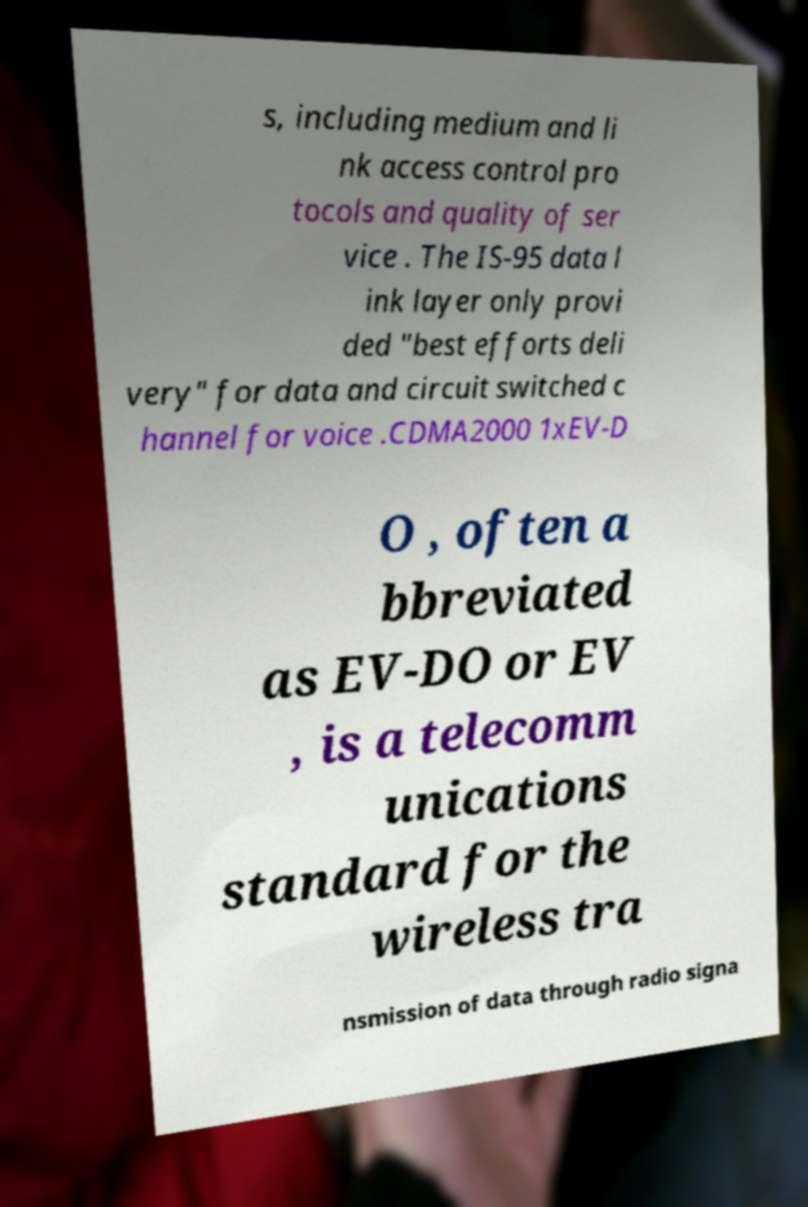For documentation purposes, I need the text within this image transcribed. Could you provide that? s, including medium and li nk access control pro tocols and quality of ser vice . The IS-95 data l ink layer only provi ded "best efforts deli very" for data and circuit switched c hannel for voice .CDMA2000 1xEV-D O , often a bbreviated as EV-DO or EV , is a telecomm unications standard for the wireless tra nsmission of data through radio signa 